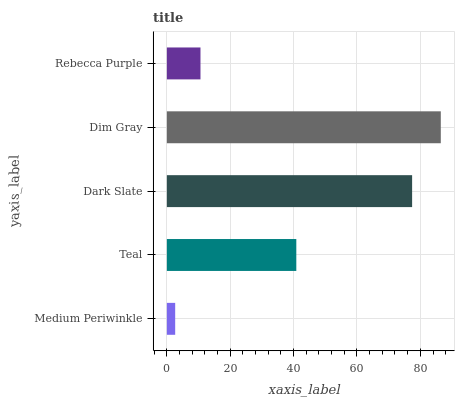Is Medium Periwinkle the minimum?
Answer yes or no. Yes. Is Dim Gray the maximum?
Answer yes or no. Yes. Is Teal the minimum?
Answer yes or no. No. Is Teal the maximum?
Answer yes or no. No. Is Teal greater than Medium Periwinkle?
Answer yes or no. Yes. Is Medium Periwinkle less than Teal?
Answer yes or no. Yes. Is Medium Periwinkle greater than Teal?
Answer yes or no. No. Is Teal less than Medium Periwinkle?
Answer yes or no. No. Is Teal the high median?
Answer yes or no. Yes. Is Teal the low median?
Answer yes or no. Yes. Is Dim Gray the high median?
Answer yes or no. No. Is Dim Gray the low median?
Answer yes or no. No. 